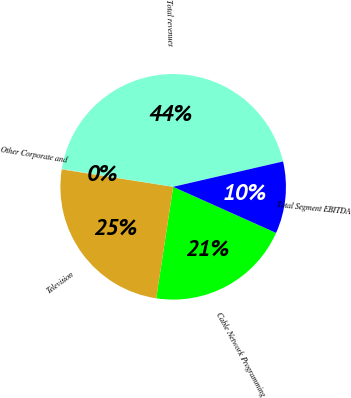Convert chart. <chart><loc_0><loc_0><loc_500><loc_500><pie_chart><fcel>Cable Network Programming<fcel>Television<fcel>Other Corporate and<fcel>Total revenues<fcel>Total Segment EBITDA<nl><fcel>20.7%<fcel>25.07%<fcel>0.11%<fcel>43.81%<fcel>10.31%<nl></chart> 